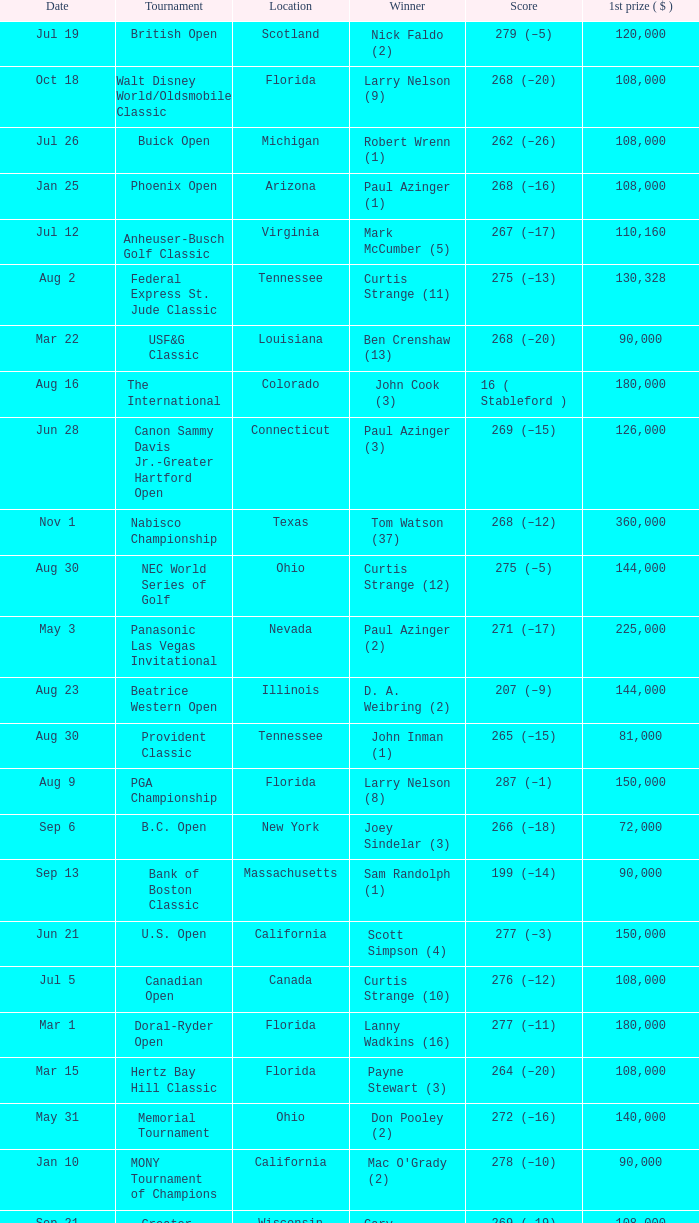What is the score from the winner Keith Clearwater (1)? 266 (–14). I'm looking to parse the entire table for insights. Could you assist me with that? {'header': ['Date', 'Tournament', 'Location', 'Winner', 'Score', '1st prize ( $ )'], 'rows': [['Jul 19', 'British Open', 'Scotland', 'Nick Faldo (2)', '279 (–5)', '120,000'], ['Oct 18', 'Walt Disney World/Oldsmobile Classic', 'Florida', 'Larry Nelson (9)', '268 (–20)', '108,000'], ['Jul 26', 'Buick Open', 'Michigan', 'Robert Wrenn (1)', '262 (–26)', '108,000'], ['Jan 25', 'Phoenix Open', 'Arizona', 'Paul Azinger (1)', '268 (–16)', '108,000'], ['Jul 12', 'Anheuser-Busch Golf Classic', 'Virginia', 'Mark McCumber (5)', '267 (–17)', '110,160'], ['Aug 2', 'Federal Express St. Jude Classic', 'Tennessee', 'Curtis Strange (11)', '275 (–13)', '130,328'], ['Mar 22', 'USF&G Classic', 'Louisiana', 'Ben Crenshaw (13)', '268 (–20)', '90,000'], ['Aug 16', 'The International', 'Colorado', 'John Cook (3)', '16 ( Stableford )', '180,000'], ['Jun 28', 'Canon Sammy Davis Jr.-Greater Hartford Open', 'Connecticut', 'Paul Azinger (3)', '269 (–15)', '126,000'], ['Nov 1', 'Nabisco Championship', 'Texas', 'Tom Watson (37)', '268 (–12)', '360,000'], ['Aug 30', 'NEC World Series of Golf', 'Ohio', 'Curtis Strange (12)', '275 (–5)', '144,000'], ['May 3', 'Panasonic Las Vegas Invitational', 'Nevada', 'Paul Azinger (2)', '271 (–17)', '225,000'], ['Aug 23', 'Beatrice Western Open', 'Illinois', 'D. A. Weibring (2)', '207 (–9)', '144,000'], ['Aug 30', 'Provident Classic', 'Tennessee', 'John Inman (1)', '265 (–15)', '81,000'], ['Aug 9', 'PGA Championship', 'Florida', 'Larry Nelson (8)', '287 (–1)', '150,000'], ['Sep 6', 'B.C. Open', 'New York', 'Joey Sindelar (3)', '266 (–18)', '72,000'], ['Sep 13', 'Bank of Boston Classic', 'Massachusetts', 'Sam Randolph (1)', '199 (–14)', '90,000'], ['Jun 21', 'U.S. Open', 'California', 'Scott Simpson (4)', '277 (–3)', '150,000'], ['Jul 5', 'Canadian Open', 'Canada', 'Curtis Strange (10)', '276 (–12)', '108,000'], ['Mar 1', 'Doral-Ryder Open', 'Florida', 'Lanny Wadkins (16)', '277 (–11)', '180,000'], ['Mar 15', 'Hertz Bay Hill Classic', 'Florida', 'Payne Stewart (3)', '264 (–20)', '108,000'], ['May 31', 'Memorial Tournament', 'Ohio', 'Don Pooley (2)', '272 (–16)', '140,000'], ['Jan 10', 'MONY Tournament of Champions', 'California', "Mac O'Grady (2)", '278 (–10)', '90,000'], ['Sep 21', 'Greater Milwaukee Open', 'Wisconsin', 'Gary Hallberg (2)', '269 (–19)', '108,000'], ['Oct 25', 'Seiko Tucson Open', 'Arizona', 'Mike Reid (1)', '268 (–20)', '108,000'], ['Mar 8', 'Honda Classic', 'Florida', 'Mark Calcavecchia (2)', '279 (–9)', '108,000'], ['May 17', 'Colonial National Invitation', 'Texas', 'Keith Clearwater (1)', '266 (–14)', '108,000'], ['Mar 29', 'Tournament Players Championship', 'Florida', 'Sandy Lyle (3)', '274 (–14)', '180,000'], ['Oct 11', 'Pensacola Open', 'Florida', 'Doug Tewell (4)', '269 (–15)', '54,000'], ['Jan 18', 'Bob Hope Chrysler Classic', 'California', 'Corey Pavin (5)', '341 (–19)', '162,000'], ['Apr 12', 'Masters Tournament', 'Georgia', 'Larry Mize (2)', '285 (–3)', '162,000'], ['Apr 26', 'Big "I" Houston Open', 'Texas', 'Jay Haas (6)', '276 (–12)', '108,000'], ['Feb 22', 'Los Angeles Open', 'California', 'T. C. Chen (1)', '275 (–9)', '108,000'], ['Oct 4', 'Southern Open', 'Georgia', 'Ken Brown (1)', '266 (–14)', '72,000'], ['Nov 1', 'Centel Classic', 'Florida', 'Keith Clearwater (2)', '278 (–10)', '90,000'], ['Sep 27', 'Southwest Golf Classic', 'Texas', 'Steve Pate (1)', '273 (–15)', '72,000'], ['May 10', 'Byron Nelson Golf Classic', 'Texas', 'Fred Couples (3)', '266 (–14)', '108,000'], ['Jul 19', "Hardee's Golf Classic", 'Illinois', 'Kenny Knox (2)', '265 (–15)', '90,000'], ['Feb 15', 'Shearson Lehman Brothers Andy Williams Open', 'California', 'George Burns (4)', '266 (–22)', '90,000'], ['Feb 1', 'AT&T Pebble Beach National Pro-Am', 'California', 'Johnny Miller (24)', '278 (–10)', '108,000'], ['Feb 8', 'Hawaiian Open', 'Hawaii', 'Corey Pavin (6)', '270 (–18)', '108,000'], ['Apr 19', 'MCI Heritage Golf Classic', 'South Carolina', 'Davis Love III (1)', '271 (–13)', '117,000'], ['May 24', 'Georgia-Pacific Atlanta Golf Classic', 'Georgia', 'Dave Barr (2)', '265 (–23)', '108,000'], ['Apr 5', 'Greater Greensboro Open', 'North Carolina', 'Scott Simpson (3)', '282 (–6)', '108,000'], ['Jun 14', 'Manufacturers Hanover Westchester Classic', 'New York', 'J. C. Snead (8)', '276 (–8)', '108,000'], ['Jun 7', 'Kemper Open', 'Maryland', 'Tom Kite (10)', '270 (–14)', '126,000']]} 